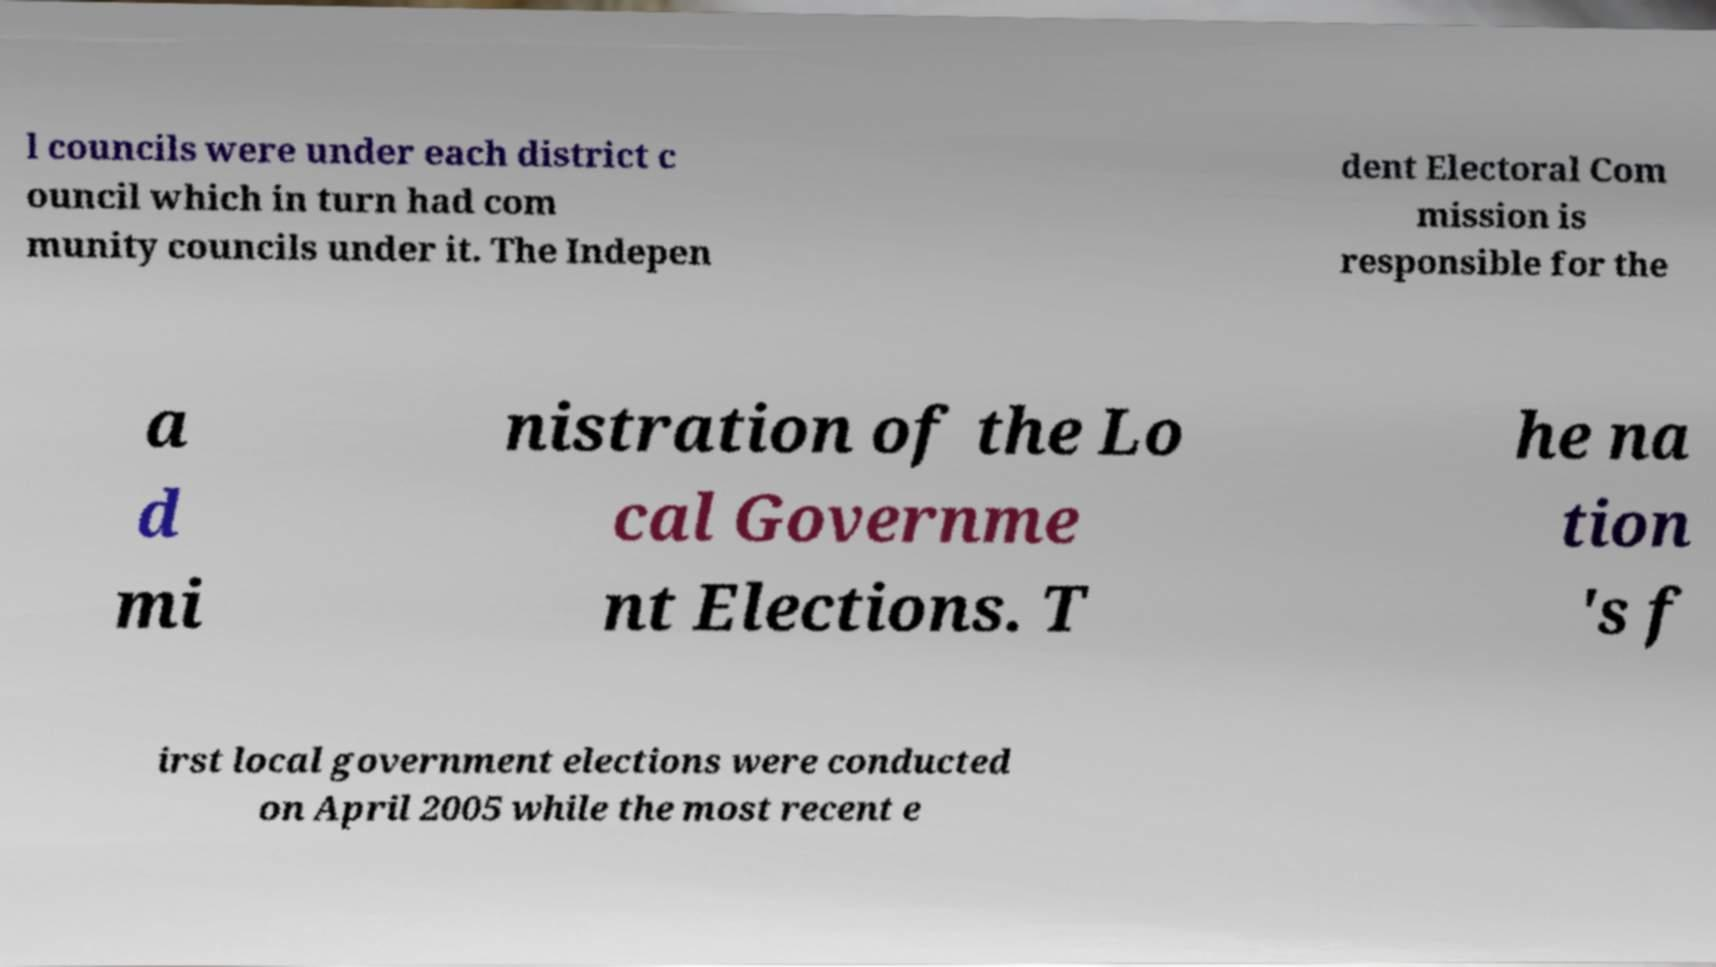Please identify and transcribe the text found in this image. l councils were under each district c ouncil which in turn had com munity councils under it. The Indepen dent Electoral Com mission is responsible for the a d mi nistration of the Lo cal Governme nt Elections. T he na tion 's f irst local government elections were conducted on April 2005 while the most recent e 